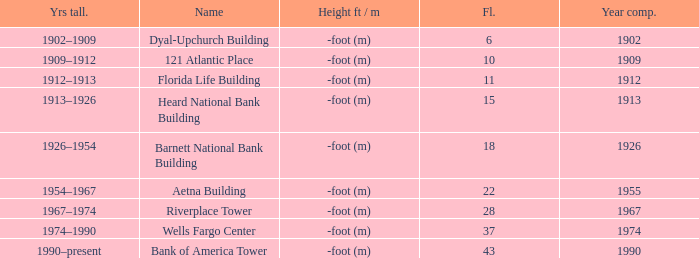What was the name of the building with 10 floors? 121 Atlantic Place. 